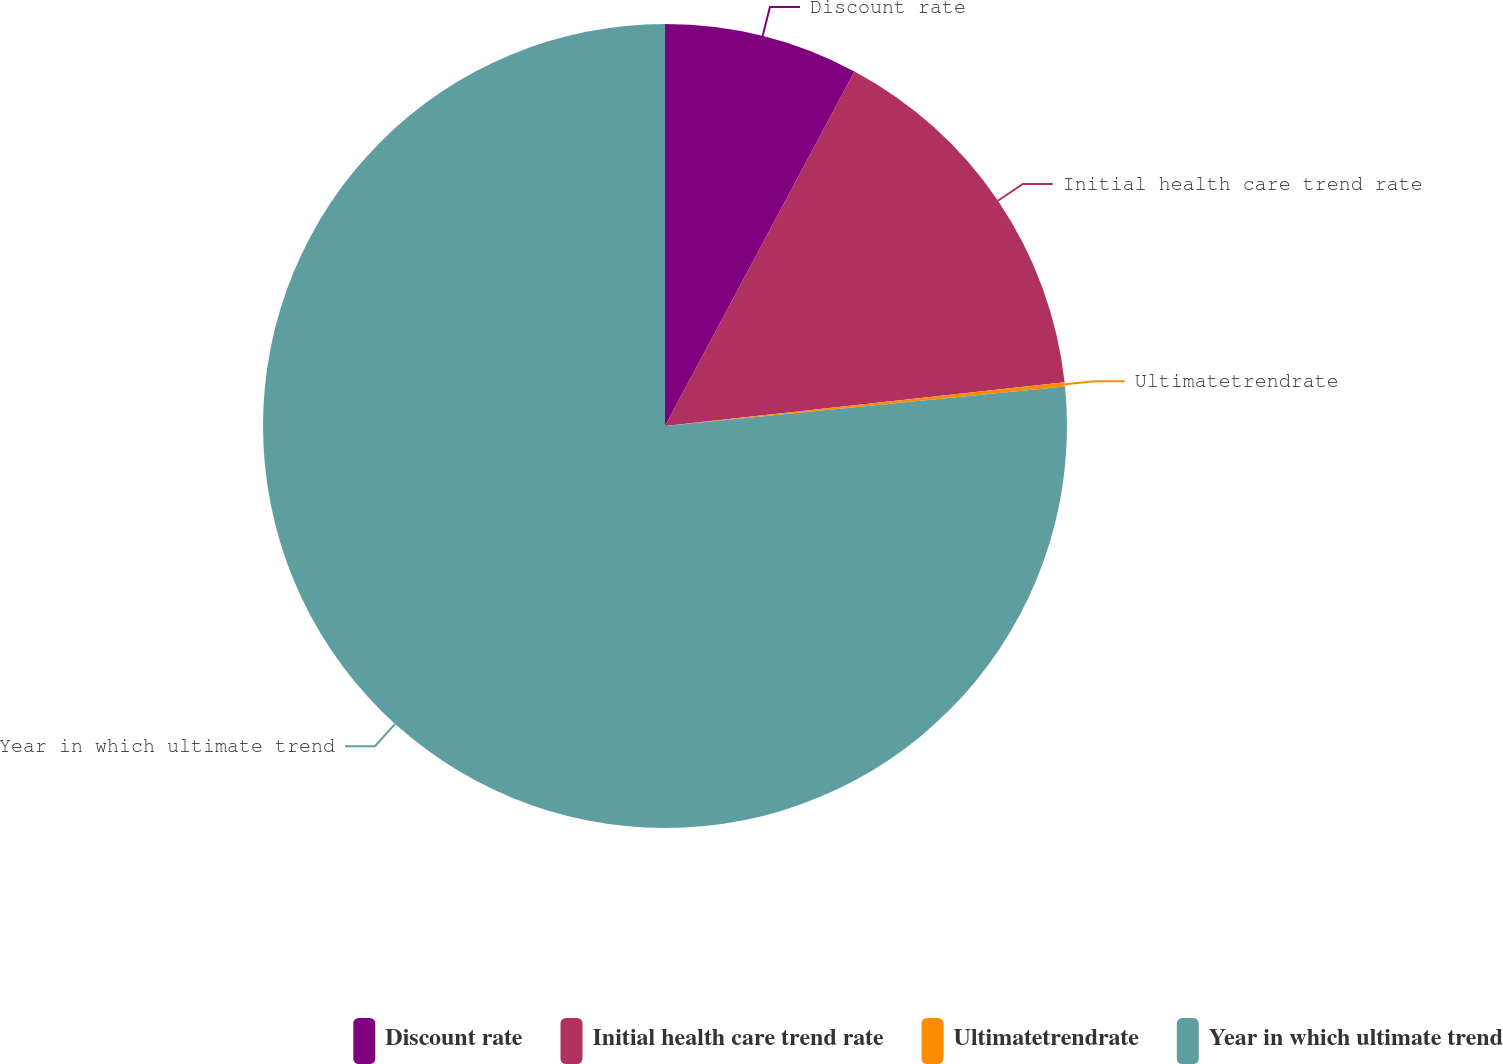<chart> <loc_0><loc_0><loc_500><loc_500><pie_chart><fcel>Discount rate<fcel>Initial health care trend rate<fcel>Ultimatetrendrate<fcel>Year in which ultimate trend<nl><fcel>7.81%<fcel>15.45%<fcel>0.17%<fcel>76.57%<nl></chart> 